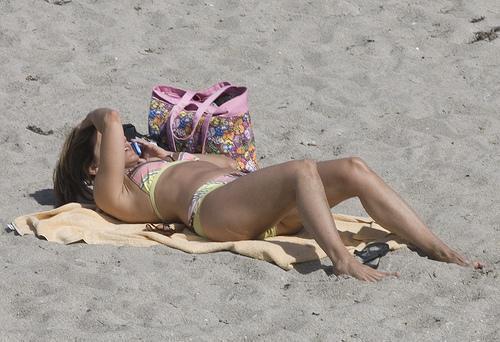How many people are in this picture?
Give a very brief answer. 1. How many bags are near the lady?
Give a very brief answer. 1. How many towels are there?
Give a very brief answer. 1. How many women are shown?
Give a very brief answer. 1. How many of this woman's hands have a cell phone in them?
Give a very brief answer. 1. 